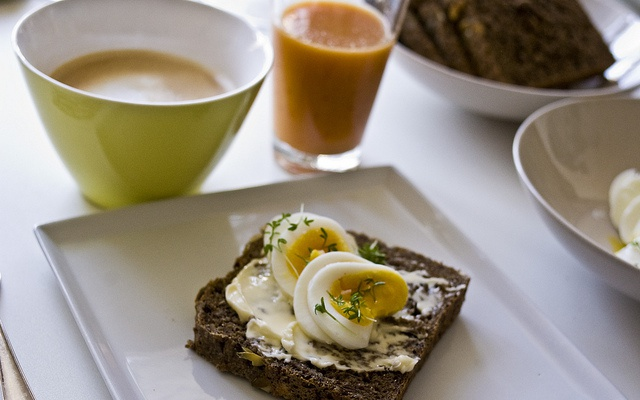Describe the objects in this image and their specific colors. I can see dining table in black, lavender, darkgray, and gray tones, cup in black, darkgray, olive, tan, and lightgray tones, sandwich in black, darkgray, olive, and tan tones, bowl in black, darkgray, and gray tones, and cup in black, maroon, olive, and lightgray tones in this image. 